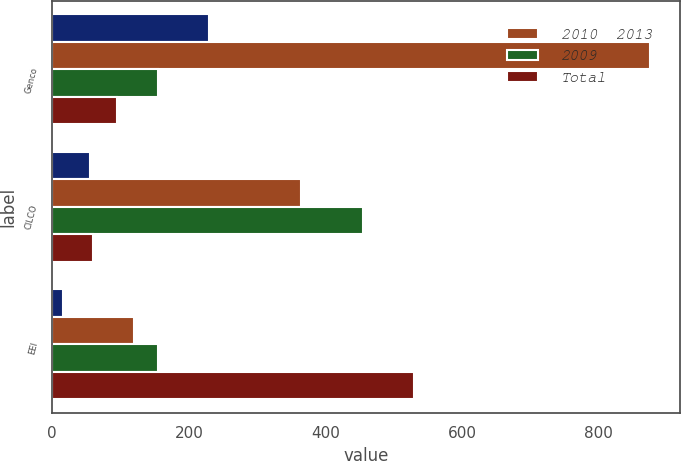Convert chart to OTSL. <chart><loc_0><loc_0><loc_500><loc_500><stacked_bar_chart><ecel><fcel>Genco<fcel>CILCO<fcel>EEI<nl><fcel>nan<fcel>230<fcel>55<fcel>15<nl><fcel>2010  2013<fcel>875<fcel>365<fcel>120<nl><fcel>2009<fcel>155<fcel>455<fcel>155<nl><fcel>Total<fcel>95<fcel>60<fcel>530<nl></chart> 